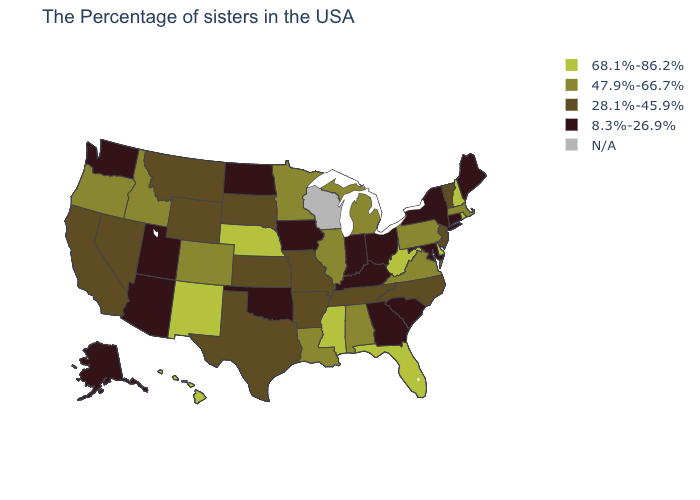Among the states that border Arizona , which have the highest value?
Keep it brief. New Mexico. Name the states that have a value in the range 28.1%-45.9%?
Quick response, please. Vermont, New Jersey, North Carolina, Tennessee, Missouri, Arkansas, Kansas, Texas, South Dakota, Wyoming, Montana, Nevada, California. Does the first symbol in the legend represent the smallest category?
Write a very short answer. No. What is the value of Ohio?
Concise answer only. 8.3%-26.9%. Does Alaska have the highest value in the USA?
Give a very brief answer. No. Which states have the lowest value in the USA?
Give a very brief answer. Maine, Connecticut, New York, Maryland, South Carolina, Ohio, Georgia, Kentucky, Indiana, Iowa, Oklahoma, North Dakota, Utah, Arizona, Washington, Alaska. What is the lowest value in the South?
Give a very brief answer. 8.3%-26.9%. What is the highest value in the USA?
Write a very short answer. 68.1%-86.2%. What is the value of New Hampshire?
Keep it brief. 68.1%-86.2%. Name the states that have a value in the range 68.1%-86.2%?
Write a very short answer. Rhode Island, New Hampshire, Delaware, West Virginia, Florida, Mississippi, Nebraska, New Mexico, Hawaii. What is the value of Nevada?
Give a very brief answer. 28.1%-45.9%. What is the highest value in the USA?
Give a very brief answer. 68.1%-86.2%. Among the states that border Texas , does New Mexico have the lowest value?
Give a very brief answer. No. What is the value of Idaho?
Concise answer only. 47.9%-66.7%. 